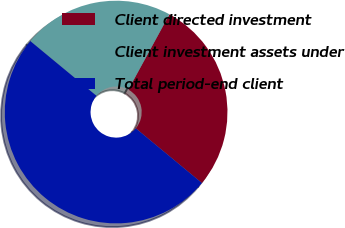Convert chart. <chart><loc_0><loc_0><loc_500><loc_500><pie_chart><fcel>Client directed investment<fcel>Client investment assets under<fcel>Total period-end client<nl><fcel>28.05%<fcel>21.95%<fcel>50.0%<nl></chart> 